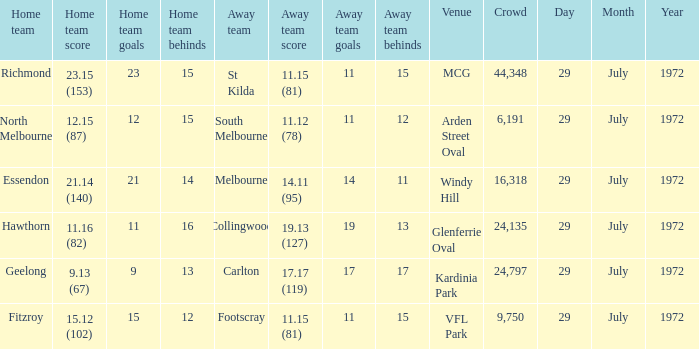When collingwood was the away team, what was the home team? Hawthorn. 